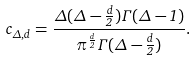<formula> <loc_0><loc_0><loc_500><loc_500>c _ { \Delta , d } = { \frac { \Delta ( \Delta - { \frac { d } { 2 } } ) \Gamma ( \Delta - 1 ) } { \pi ^ { \frac { d } { 2 } } \Gamma ( \Delta - { \frac { d } { 2 } } ) } } .</formula> 